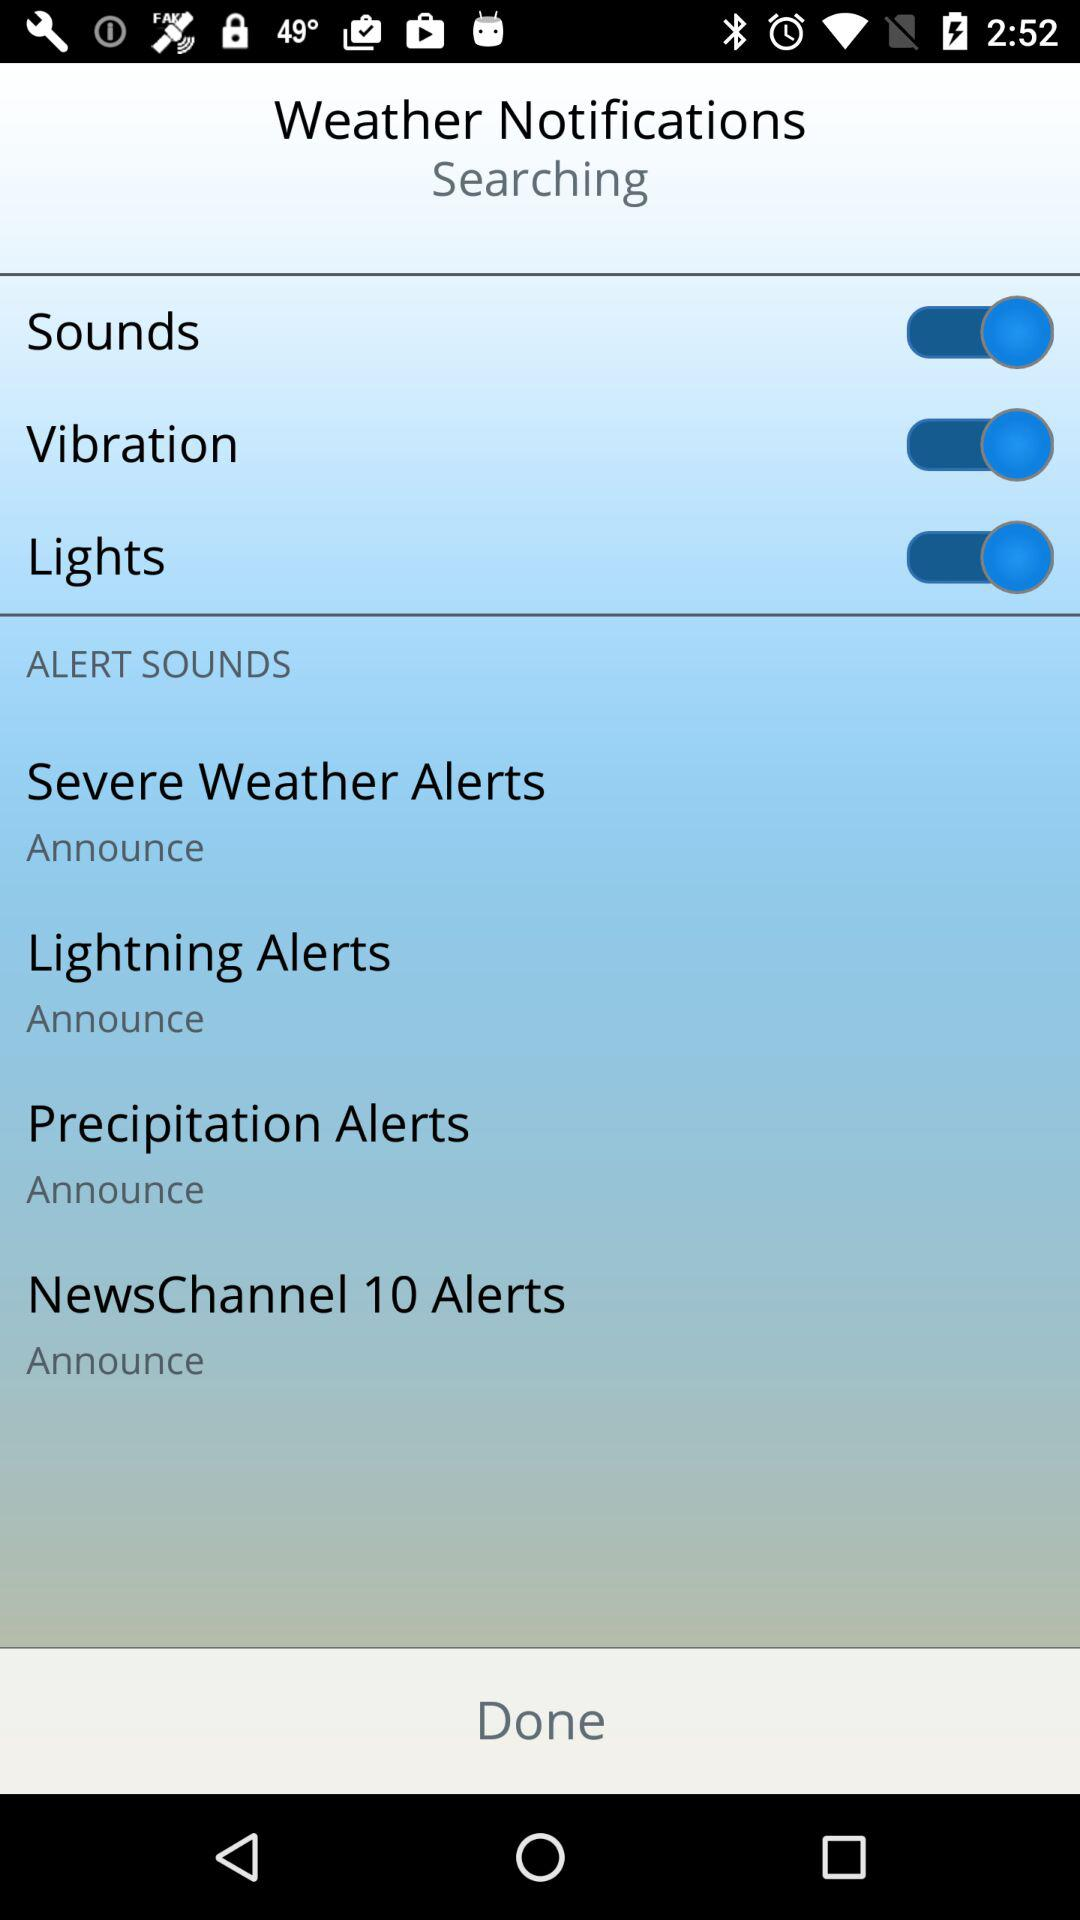What is the status of "Sounds"? The status is "on". 